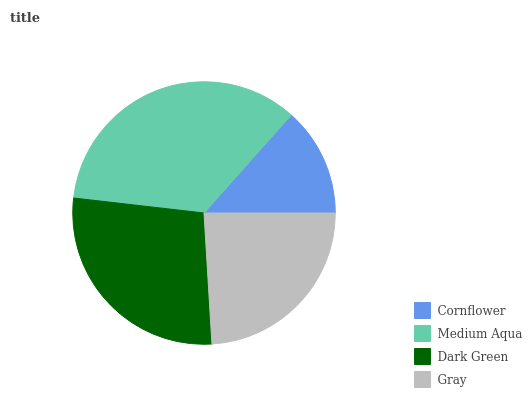Is Cornflower the minimum?
Answer yes or no. Yes. Is Medium Aqua the maximum?
Answer yes or no. Yes. Is Dark Green the minimum?
Answer yes or no. No. Is Dark Green the maximum?
Answer yes or no. No. Is Medium Aqua greater than Dark Green?
Answer yes or no. Yes. Is Dark Green less than Medium Aqua?
Answer yes or no. Yes. Is Dark Green greater than Medium Aqua?
Answer yes or no. No. Is Medium Aqua less than Dark Green?
Answer yes or no. No. Is Dark Green the high median?
Answer yes or no. Yes. Is Gray the low median?
Answer yes or no. Yes. Is Medium Aqua the high median?
Answer yes or no. No. Is Dark Green the low median?
Answer yes or no. No. 